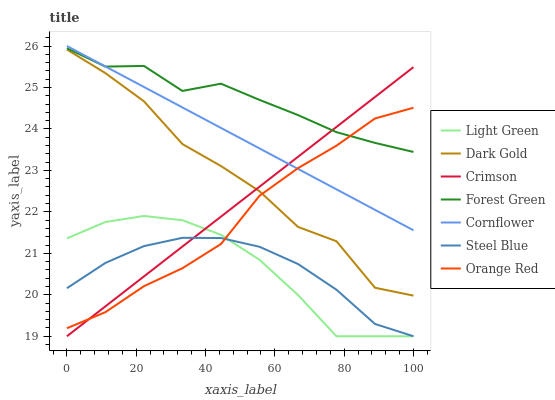Does Steel Blue have the minimum area under the curve?
Answer yes or no. Yes. Does Forest Green have the maximum area under the curve?
Answer yes or no. Yes. Does Dark Gold have the minimum area under the curve?
Answer yes or no. No. Does Dark Gold have the maximum area under the curve?
Answer yes or no. No. Is Crimson the smoothest?
Answer yes or no. Yes. Is Dark Gold the roughest?
Answer yes or no. Yes. Is Steel Blue the smoothest?
Answer yes or no. No. Is Steel Blue the roughest?
Answer yes or no. No. Does Steel Blue have the lowest value?
Answer yes or no. Yes. Does Dark Gold have the lowest value?
Answer yes or no. No. Does Cornflower have the highest value?
Answer yes or no. Yes. Does Dark Gold have the highest value?
Answer yes or no. No. Is Light Green less than Dark Gold?
Answer yes or no. Yes. Is Cornflower greater than Dark Gold?
Answer yes or no. Yes. Does Light Green intersect Steel Blue?
Answer yes or no. Yes. Is Light Green less than Steel Blue?
Answer yes or no. No. Is Light Green greater than Steel Blue?
Answer yes or no. No. Does Light Green intersect Dark Gold?
Answer yes or no. No. 